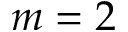Convert formula to latex. <formula><loc_0><loc_0><loc_500><loc_500>m = 2</formula> 